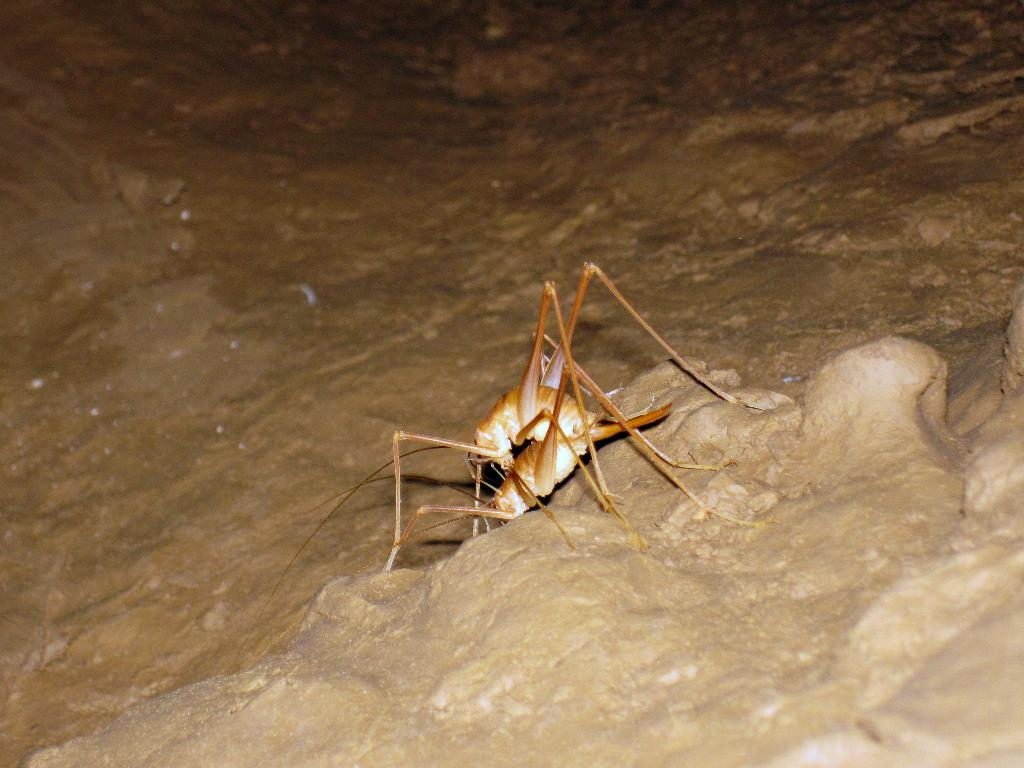What type of creature is present in the image? There is an insect in the image. Where is the insect located in the image? The insect is on a surface. What comparison can be made between the insect and the mom in the image? There is no mom present in the image, so no comparison can be made. 